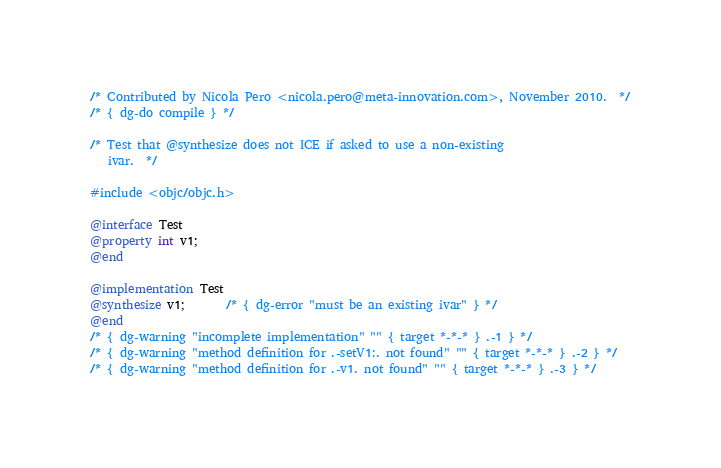Convert code to text. <code><loc_0><loc_0><loc_500><loc_500><_ObjectiveC_>/* Contributed by Nicola Pero <nicola.pero@meta-innovation.com>, November 2010.  */
/* { dg-do compile } */

/* Test that @synthesize does not ICE if asked to use a non-existing
   ivar.  */

#include <objc/objc.h>

@interface Test
@property int v1;
@end

@implementation Test
@synthesize v1;       /* { dg-error "must be an existing ivar" } */
@end
/* { dg-warning "incomplete implementation" "" { target *-*-* } .-1 } */
/* { dg-warning "method definition for .-setV1:. not found" "" { target *-*-* } .-2 } */
/* { dg-warning "method definition for .-v1. not found" "" { target *-*-* } .-3 } */
</code> 